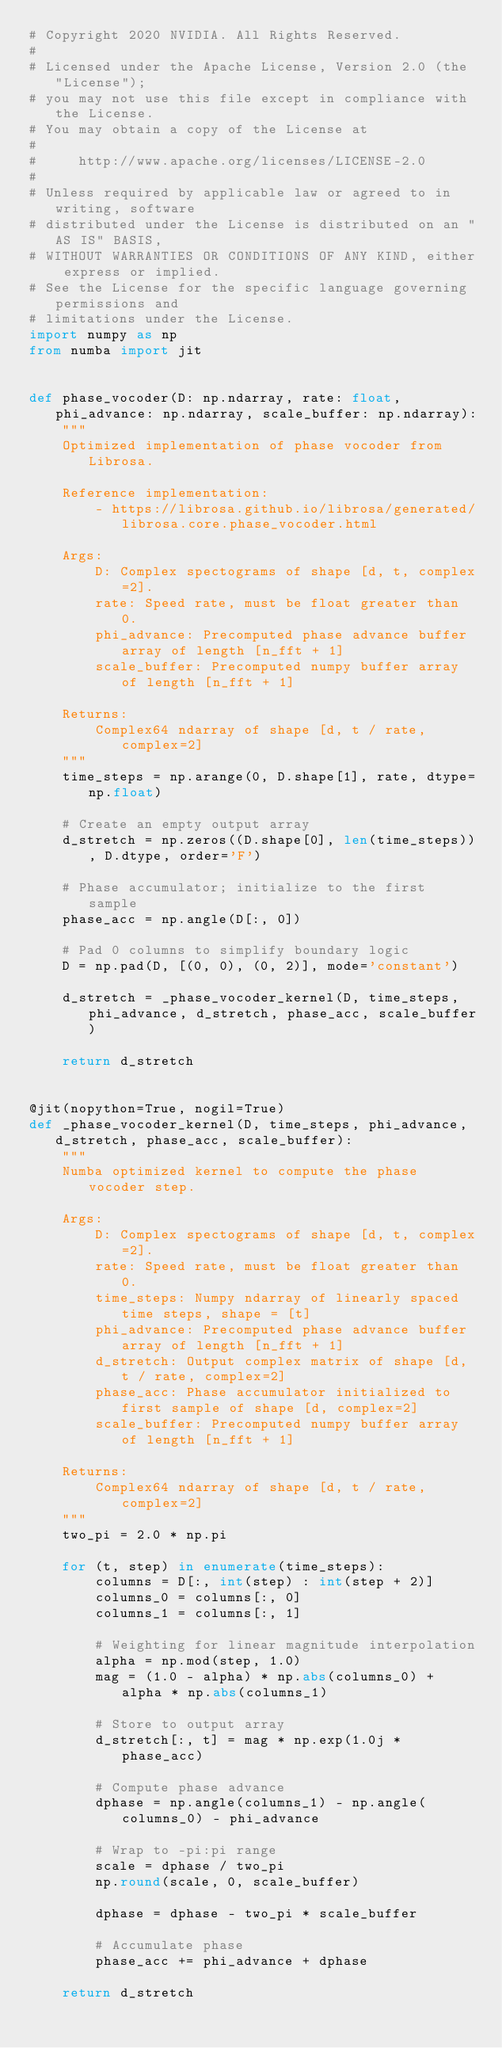Convert code to text. <code><loc_0><loc_0><loc_500><loc_500><_Python_># Copyright 2020 NVIDIA. All Rights Reserved.
#
# Licensed under the Apache License, Version 2.0 (the "License");
# you may not use this file except in compliance with the License.
# You may obtain a copy of the License at
#
#     http://www.apache.org/licenses/LICENSE-2.0
#
# Unless required by applicable law or agreed to in writing, software
# distributed under the License is distributed on an "AS IS" BASIS,
# WITHOUT WARRANTIES OR CONDITIONS OF ANY KIND, either express or implied.
# See the License for the specific language governing permissions and
# limitations under the License.
import numpy as np
from numba import jit


def phase_vocoder(D: np.ndarray, rate: float, phi_advance: np.ndarray, scale_buffer: np.ndarray):
    """
    Optimized implementation of phase vocoder from Librosa.

    Reference implementation:
        - https://librosa.github.io/librosa/generated/librosa.core.phase_vocoder.html

    Args:
        D: Complex spectograms of shape [d, t, complex=2].
        rate: Speed rate, must be float greater than 0.
        phi_advance: Precomputed phase advance buffer array of length [n_fft + 1]
        scale_buffer: Precomputed numpy buffer array of length [n_fft + 1]

    Returns:
        Complex64 ndarray of shape [d, t / rate, complex=2]
    """
    time_steps = np.arange(0, D.shape[1], rate, dtype=np.float)

    # Create an empty output array
    d_stretch = np.zeros((D.shape[0], len(time_steps)), D.dtype, order='F')

    # Phase accumulator; initialize to the first sample
    phase_acc = np.angle(D[:, 0])

    # Pad 0 columns to simplify boundary logic
    D = np.pad(D, [(0, 0), (0, 2)], mode='constant')

    d_stretch = _phase_vocoder_kernel(D, time_steps, phi_advance, d_stretch, phase_acc, scale_buffer)

    return d_stretch


@jit(nopython=True, nogil=True)
def _phase_vocoder_kernel(D, time_steps, phi_advance, d_stretch, phase_acc, scale_buffer):
    """
    Numba optimized kernel to compute the phase vocoder step.

    Args:
        D: Complex spectograms of shape [d, t, complex=2].
        rate: Speed rate, must be float greater than 0.
        time_steps: Numpy ndarray of linearly spaced time steps, shape = [t]
        phi_advance: Precomputed phase advance buffer array of length [n_fft + 1]
        d_stretch: Output complex matrix of shape [d, t / rate, complex=2]
        phase_acc: Phase accumulator initialized to first sample of shape [d, complex=2]
        scale_buffer: Precomputed numpy buffer array of length [n_fft + 1]

    Returns:
        Complex64 ndarray of shape [d, t / rate, complex=2]
    """
    two_pi = 2.0 * np.pi

    for (t, step) in enumerate(time_steps):
        columns = D[:, int(step) : int(step + 2)]
        columns_0 = columns[:, 0]
        columns_1 = columns[:, 1]

        # Weighting for linear magnitude interpolation
        alpha = np.mod(step, 1.0)
        mag = (1.0 - alpha) * np.abs(columns_0) + alpha * np.abs(columns_1)

        # Store to output array
        d_stretch[:, t] = mag * np.exp(1.0j * phase_acc)

        # Compute phase advance
        dphase = np.angle(columns_1) - np.angle(columns_0) - phi_advance

        # Wrap to -pi:pi range
        scale = dphase / two_pi
        np.round(scale, 0, scale_buffer)

        dphase = dphase - two_pi * scale_buffer

        # Accumulate phase
        phase_acc += phi_advance + dphase

    return d_stretch
</code> 